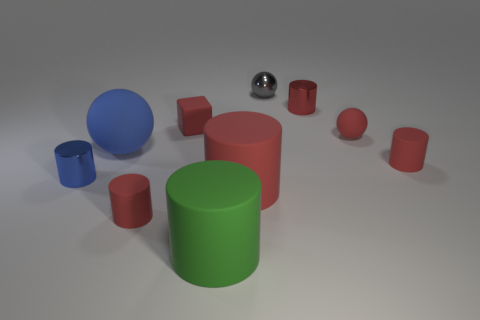There is a tiny thing that is behind the red rubber cube and right of the gray metallic ball; what is its material?
Offer a terse response. Metal. Do the thing to the right of the tiny rubber sphere and the red cylinder that is behind the blue rubber object have the same material?
Ensure brevity in your answer.  No. There is a green thing that is the same shape as the tiny red shiny thing; what size is it?
Provide a short and direct response. Large. Is the tiny cylinder in front of the blue metal cylinder made of the same material as the small red sphere?
Provide a succinct answer. Yes. Is the shape of the big green rubber thing the same as the big red rubber object?
Ensure brevity in your answer.  Yes. What number of things are either blue balls that are to the left of the large red cylinder or gray metal things?
Keep it short and to the point. 2. There is a red sphere that is the same material as the red cube; what size is it?
Your answer should be compact. Small. What number of cylinders have the same color as the large matte ball?
Provide a short and direct response. 1. How many large objects are green rubber cylinders or blue cylinders?
Offer a terse response. 1. There is a matte sphere that is the same color as the tiny matte cube; what is its size?
Offer a very short reply. Small. 